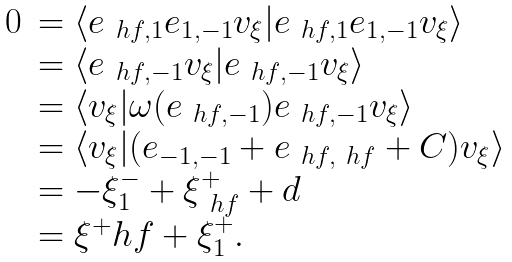Convert formula to latex. <formula><loc_0><loc_0><loc_500><loc_500>\begin{array} { l l } 0 & = \langle e _ { \ h f , 1 } e _ { 1 , - 1 } v _ { \xi } | e _ { \ h f , 1 } e _ { 1 , - 1 } v _ { \xi } \rangle \\ & = \langle e _ { \ h f , - 1 } v _ { \xi } | e _ { \ h f , - 1 } v _ { \xi } \rangle \\ & = \langle v _ { \xi } | \omega ( e _ { \ h f , - 1 } ) e _ { \ h f , - 1 } v _ { \xi } \rangle \\ & = \langle v _ { \xi } | ( e _ { - 1 , - 1 } + e _ { \ h f , \ h f } + C ) v _ { \xi } \rangle \\ & = - \xi ^ { - } _ { 1 } + \xi ^ { + } _ { \ h f } + d \\ & = \xi ^ { + } _ { \ } h f + \xi ^ { + } _ { 1 } . \\ \end{array}</formula> 